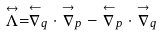<formula> <loc_0><loc_0><loc_500><loc_500>\stackrel { \leftrightarrow } { \Lambda } = \stackrel { \leftarrow } { \nabla } _ { q } \cdot \stackrel { \rightarrow } { \nabla } _ { p } - \stackrel { \leftarrow } { \nabla } _ { p } \cdot \stackrel { \rightarrow } { \nabla } _ { q }</formula> 